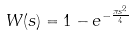Convert formula to latex. <formula><loc_0><loc_0><loc_500><loc_500>W ( s ) = 1 - e ^ { - \frac { \pi s ^ { 2 } } { 4 } }</formula> 